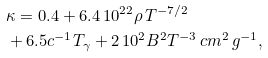<formula> <loc_0><loc_0><loc_500><loc_500>& \kappa = 0 . 4 + 6 . 4 \, 1 0 ^ { 2 2 } \rho \, T ^ { - 7 / 2 } \\ & + 6 . 5 c ^ { - 1 } T _ { \gamma } + 2 \, 1 0 ^ { 2 } B ^ { 2 } T ^ { - 3 } \, c m ^ { 2 } \, g ^ { - 1 } ,</formula> 